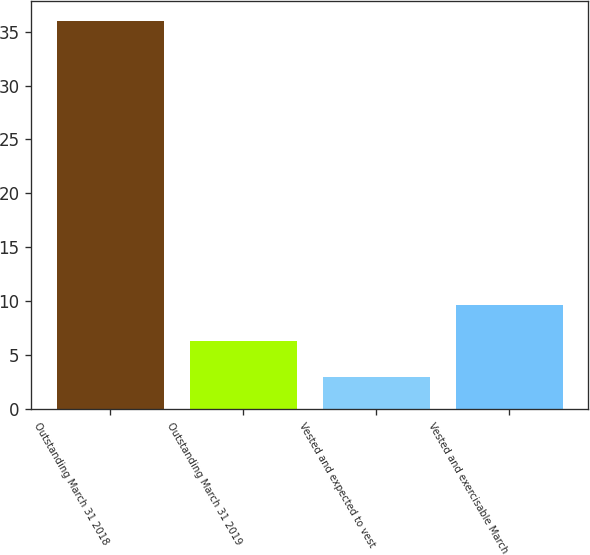Convert chart to OTSL. <chart><loc_0><loc_0><loc_500><loc_500><bar_chart><fcel>Outstanding March 31 2018<fcel>Outstanding March 31 2019<fcel>Vested and expected to vest<fcel>Vested and exercisable March<nl><fcel>36<fcel>6.3<fcel>3<fcel>9.6<nl></chart> 